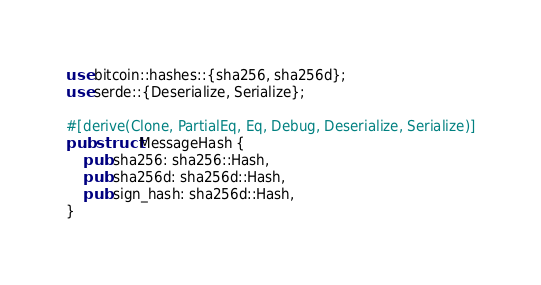Convert code to text. <code><loc_0><loc_0><loc_500><loc_500><_Rust_>use bitcoin::hashes::{sha256, sha256d};
use serde::{Deserialize, Serialize};

#[derive(Clone, PartialEq, Eq, Debug, Deserialize, Serialize)]
pub struct MessageHash {
	pub sha256: sha256::Hash,
	pub sha256d: sha256d::Hash,
	pub sign_hash: sha256d::Hash,
}
</code> 